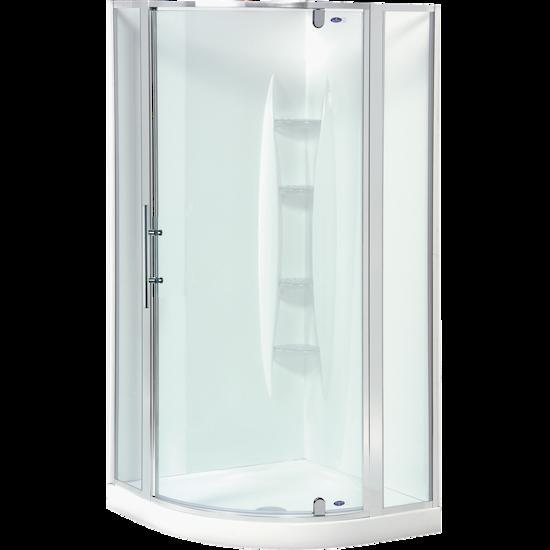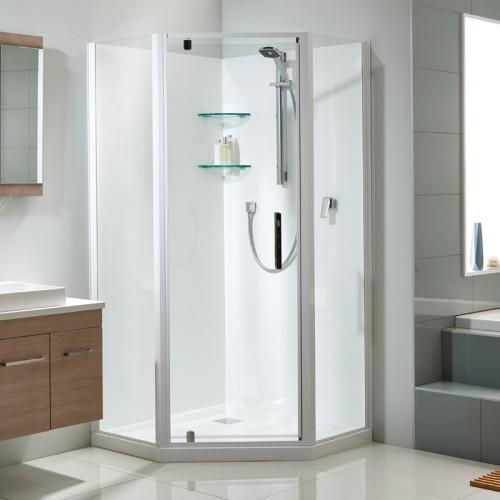The first image is the image on the left, the second image is the image on the right. Given the left and right images, does the statement "The shower in the image on the left if against a solid color background." hold true? Answer yes or no. Yes. 